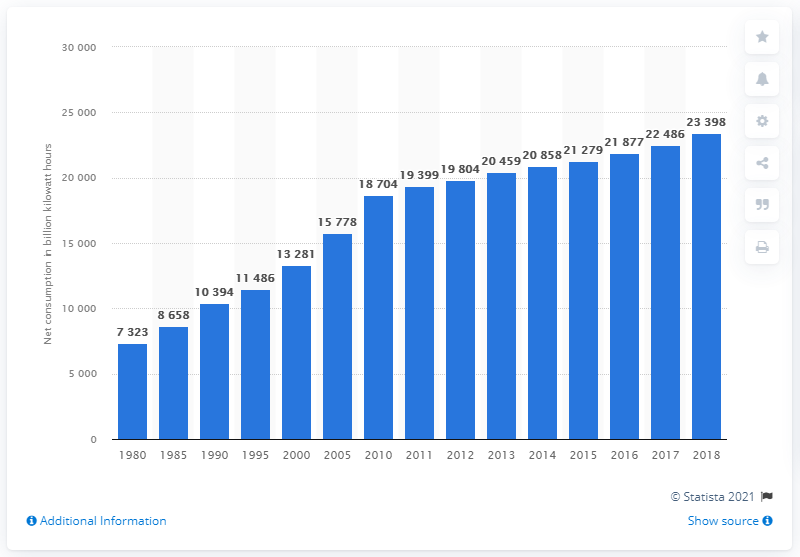Mention a couple of crucial points in this snapshot. The growth of global power began to become more pronounced in the year 2000. 